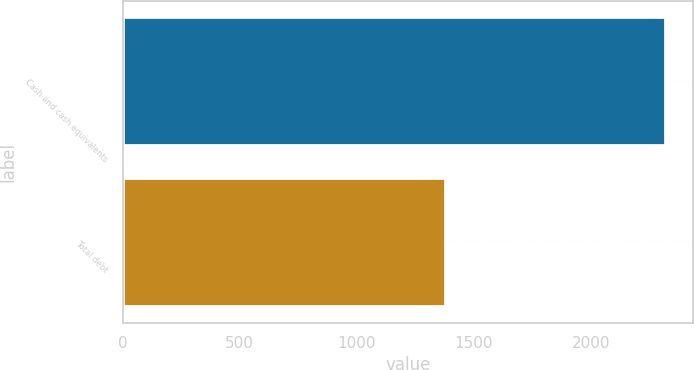Convert chart to OTSL. <chart><loc_0><loc_0><loc_500><loc_500><bar_chart><fcel>Cash and cash equivalents<fcel>Total debt<nl><fcel>2319<fcel>1379<nl></chart> 